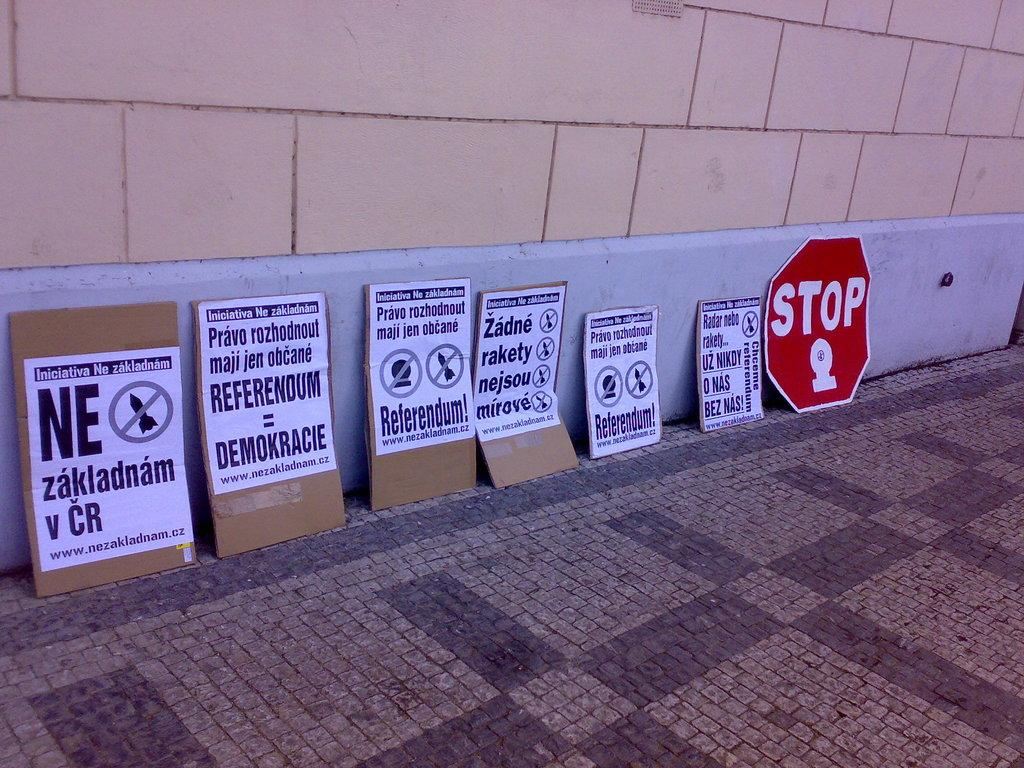<image>
Present a compact description of the photo's key features. Several protest posters rest against a wall to the left of one poster that says STOP. 